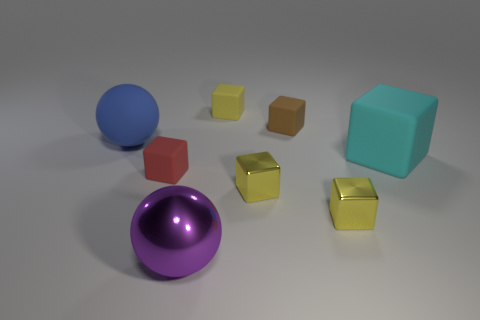Subtract all green cylinders. How many yellow cubes are left? 3 Subtract all big cyan rubber blocks. How many blocks are left? 5 Subtract all brown cubes. How many cubes are left? 5 Subtract all purple spheres. Subtract all red cubes. How many spheres are left? 1 Add 2 large cyan matte objects. How many objects exist? 10 Subtract all spheres. How many objects are left? 6 Subtract all cyan things. Subtract all big blue rubber balls. How many objects are left? 6 Add 2 small brown rubber cubes. How many small brown rubber cubes are left? 3 Add 7 red blocks. How many red blocks exist? 8 Subtract 0 cyan spheres. How many objects are left? 8 